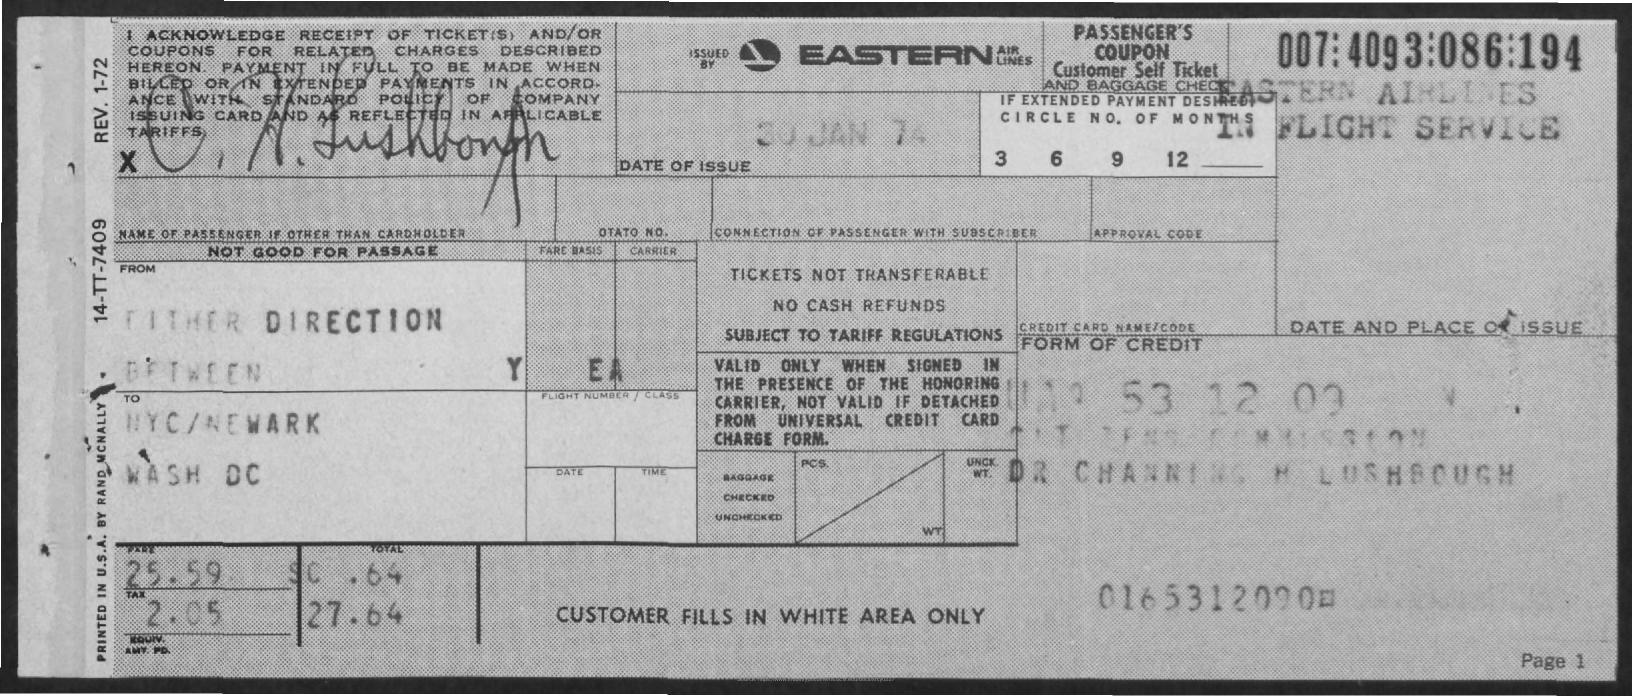Outline some significant characteristics in this image. What is the name of the airlines?" "Eastern. The date of issue is January 30, 1974. 